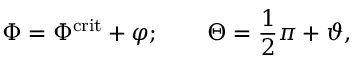Convert formula to latex. <formula><loc_0><loc_0><loc_500><loc_500>\Phi = \Phi ^ { c r i t } + \varphi ; \quad \Theta = \frac { 1 } { 2 } \pi + \vartheta ,</formula> 